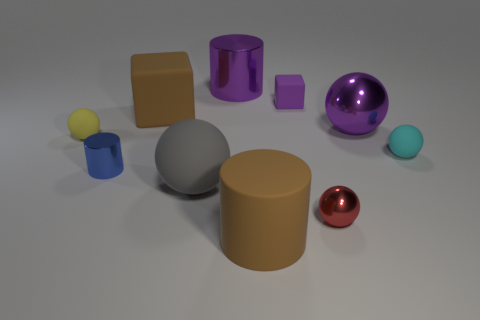What purpose could these objects serve in a real-world setting? These objects seem reminiscent of educational models or toys used to teach about shapes, volume, and geometry. Their distinct colors and simple geometric forms could also make them useful as visual aids in a design or art class, to demonstrate concepts of color theory and object composition. 